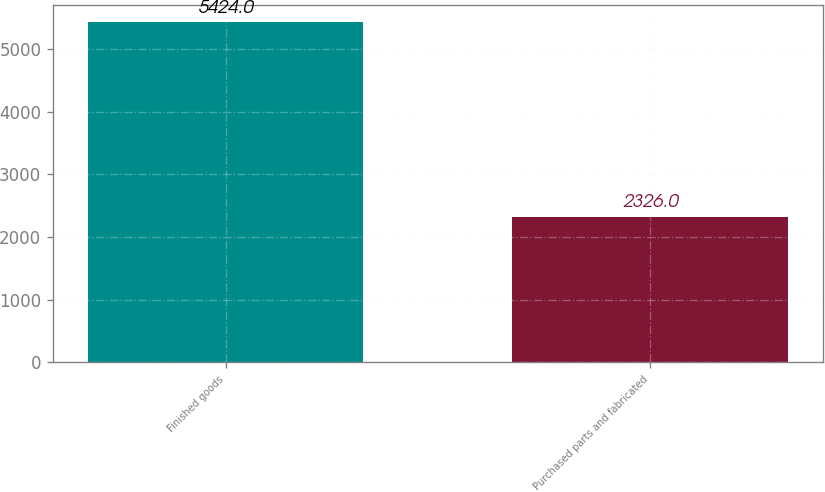Convert chart. <chart><loc_0><loc_0><loc_500><loc_500><bar_chart><fcel>Finished goods<fcel>Purchased parts and fabricated<nl><fcel>5424<fcel>2326<nl></chart> 